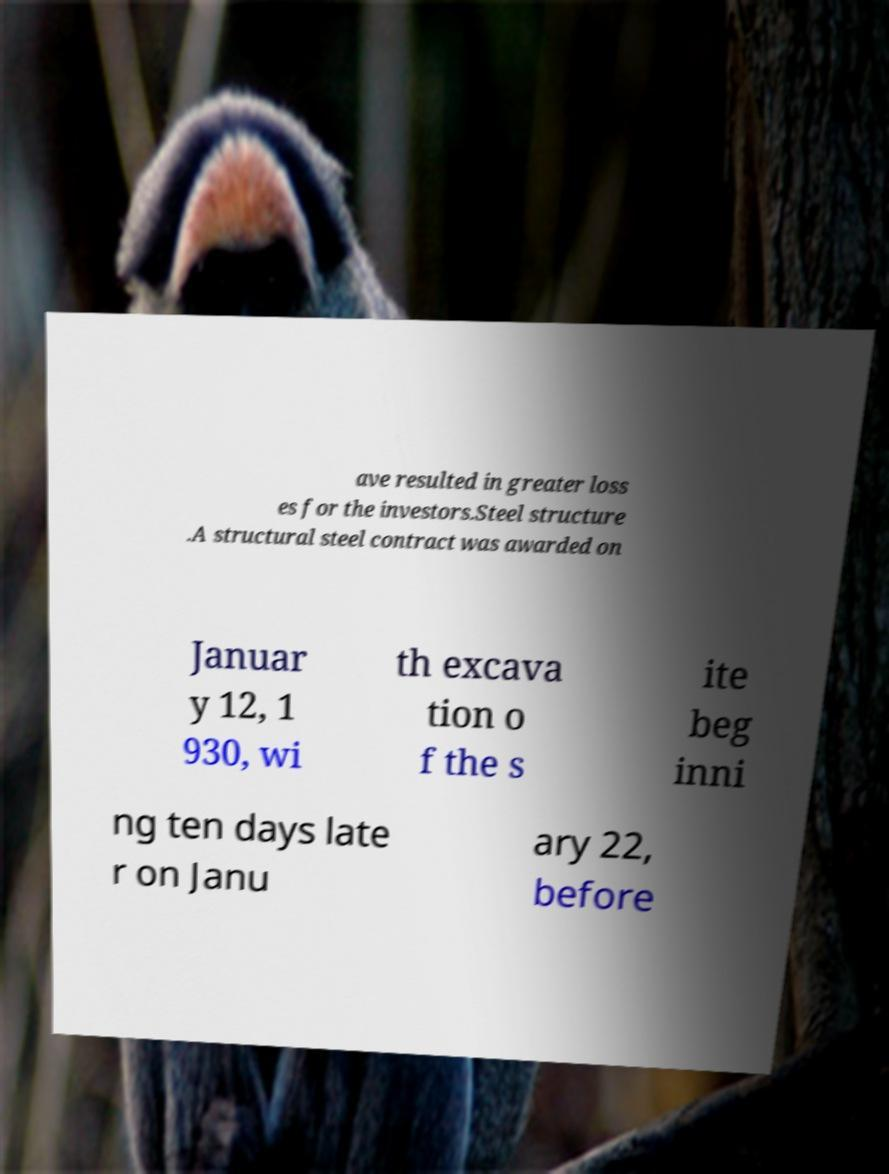Can you accurately transcribe the text from the provided image for me? ave resulted in greater loss es for the investors.Steel structure .A structural steel contract was awarded on Januar y 12, 1 930, wi th excava tion o f the s ite beg inni ng ten days late r on Janu ary 22, before 